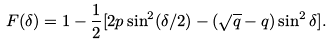Convert formula to latex. <formula><loc_0><loc_0><loc_500><loc_500>F ( \delta ) = 1 - \frac { 1 } { 2 } [ 2 p \sin ^ { 2 } ( \delta / 2 ) - ( \sqrt { q } - q ) \sin ^ { 2 } \delta ] .</formula> 